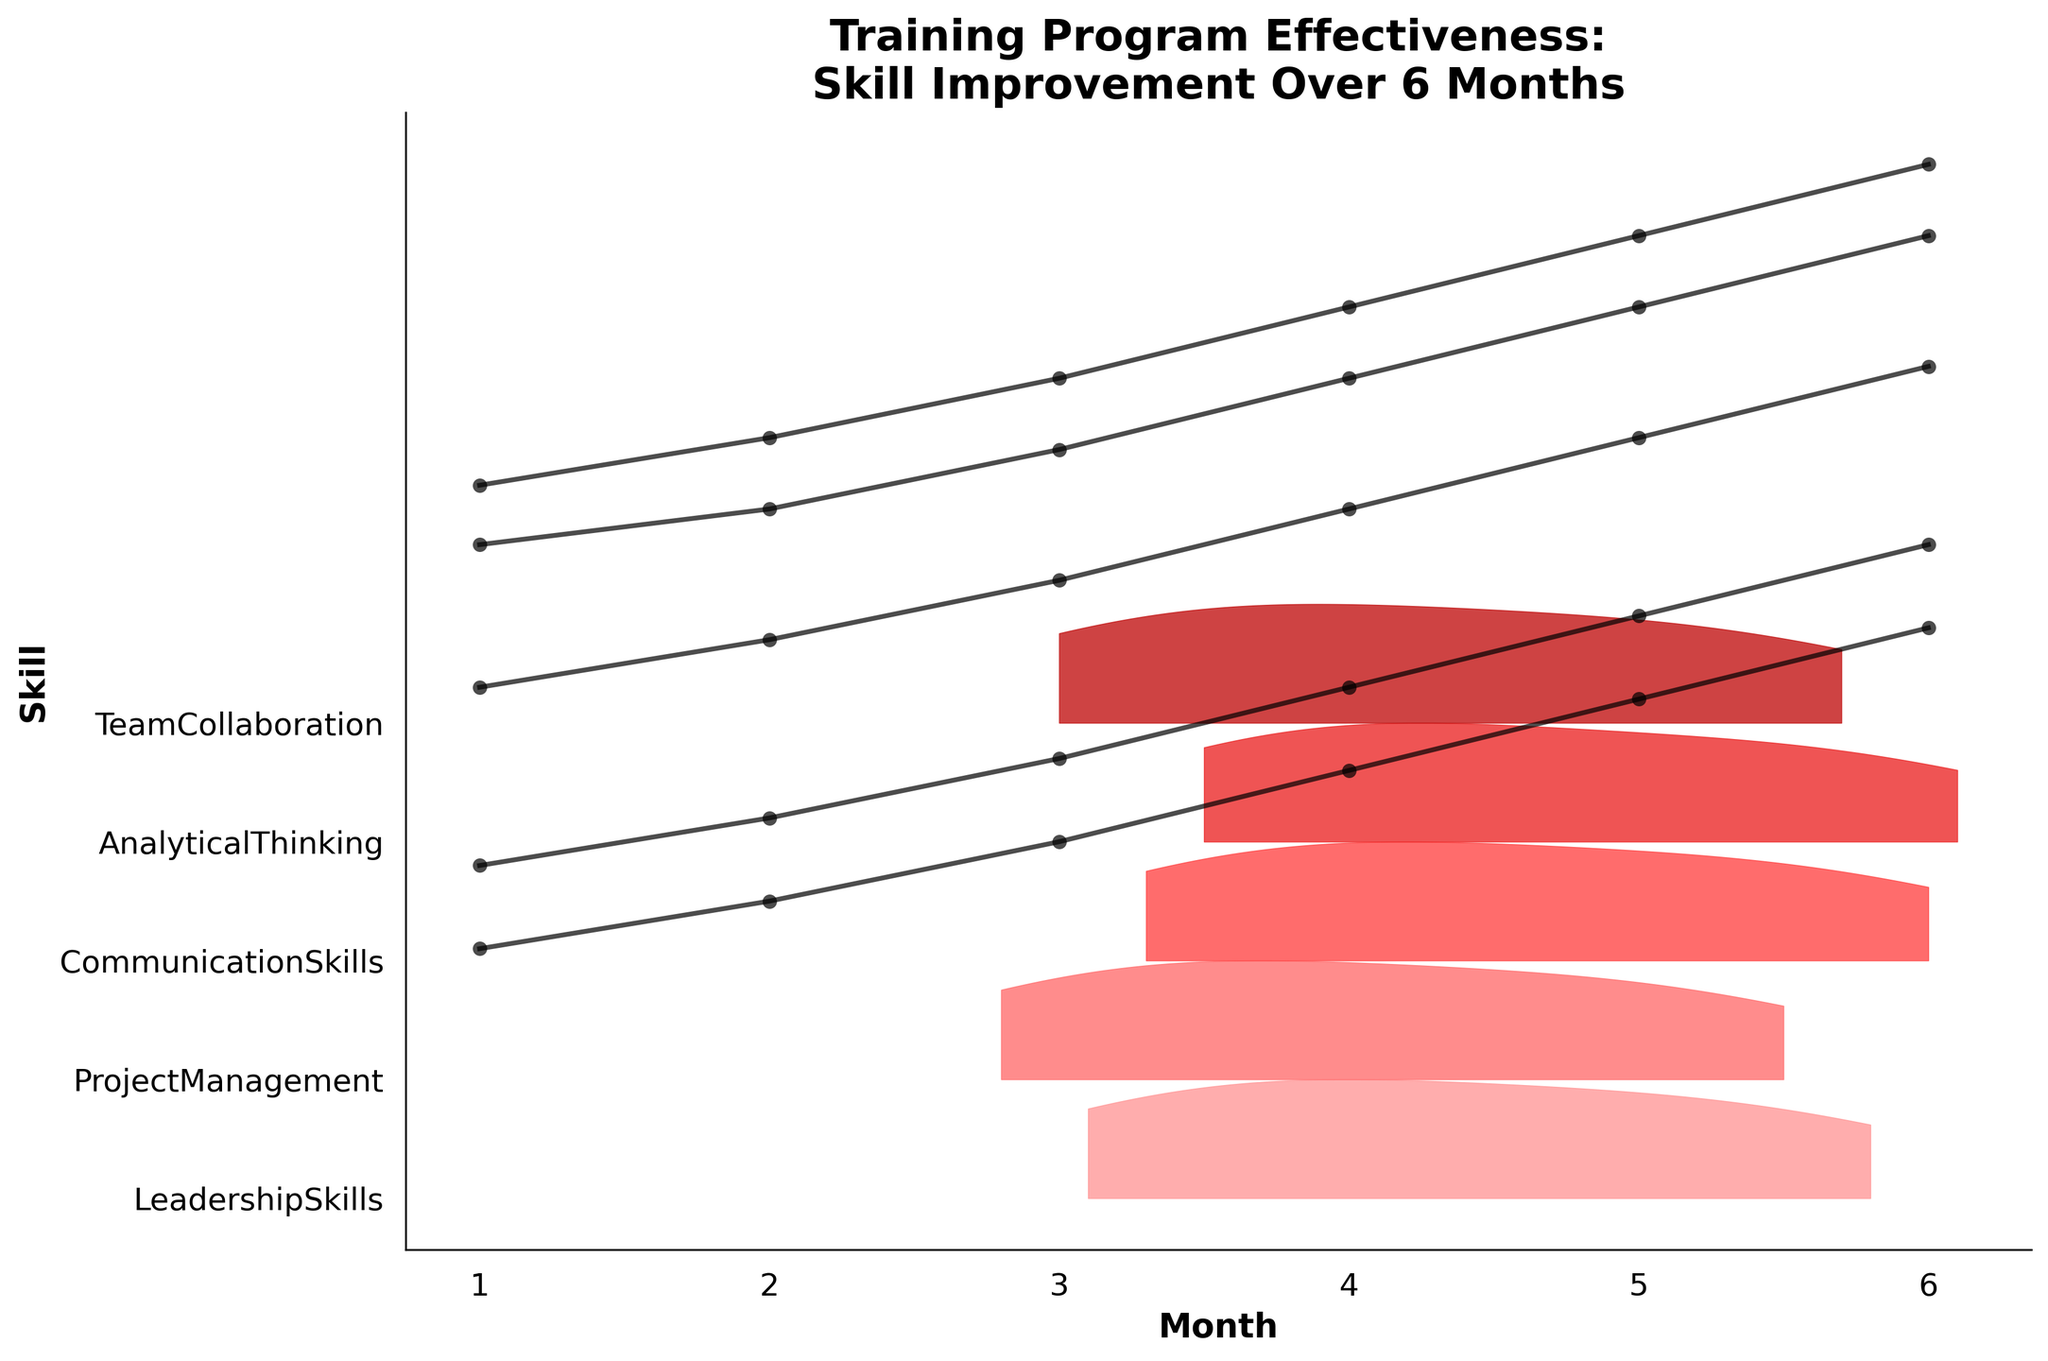What is the title of the figure? The title is usually displayed at the top of the figure and provides a summary of what the figure is about. The title in this case is "Training Program Effectiveness: Skill Improvement Over 6 Months."
Answer: Training Program Effectiveness: Skill Improvement Over 6 Months Which skill shows the highest improvement in month 6? To determine which skill shows the highest improvement, look at the values for each skill in month 6. The highest value will indicate the greatest improvement.
Answer: Communication Skills How many months are represented in the figure? Count the number of x-axis ticks or the labeled months on the figure. The x-axis represents the months in the period.
Answer: 6 Which skill had the least improvement by month 3? Compare the values for each skill in month 3 and identify the lowest value. The skill associated with this value had the least improvement by this month.
Answer: Project Management What's the range of Analytical Thinking improvement scores from month 1 to month 6? The range is calculated by subtracting the lowest score from the highest score for Analytical Thinking over the months. Subtract the month 1 value from the month 6 value.
Answer: 2.6 (5.1 - 2.5) Does Team Collaboration show a consistent improvement over the months? Review the trend for Team Collaboration from month to month; a consistent improvement would mean that scores are steadily increasing without any decrease.
Answer: Yes How do Communication Skills in month 4 compare to those in month 2? Compare the values for Communication Skills in month 4 and month 2 to see if they have increased, decreased, or remained the same.
Answer: Increased (3.8 > 2.7) What's the average skill improvement for Project Management over the 6 months? Calculate the average by summing the monthly values for Project Management and dividing by the number of months (6).
Answer: 3.1 ((1.8 + 2.2 + 2.7 + 3.3 + 3.9 + 4.5) / 6 = 3.1) Which skill shows the steepest improvement between any two consecutive months? Identify the pair of consecutive months between which the value of any skill has increased by the highest amount. Subtract the earlier month’s value from the later month’s value for each skill to find the largest change.
Answer: Analytical Thinking (Month 1 to Month 2) What colors represent the ridgelines for skills in the plot? The colors used in the ridgelines often follow a gradient or colormap. Identify the sequence of colors based on visual inspection. In this case, it ranges from lighter red to darker red ("#FF9999", "#FF3333", "#990000").
Answer: Shades of red ranging from light to dark 